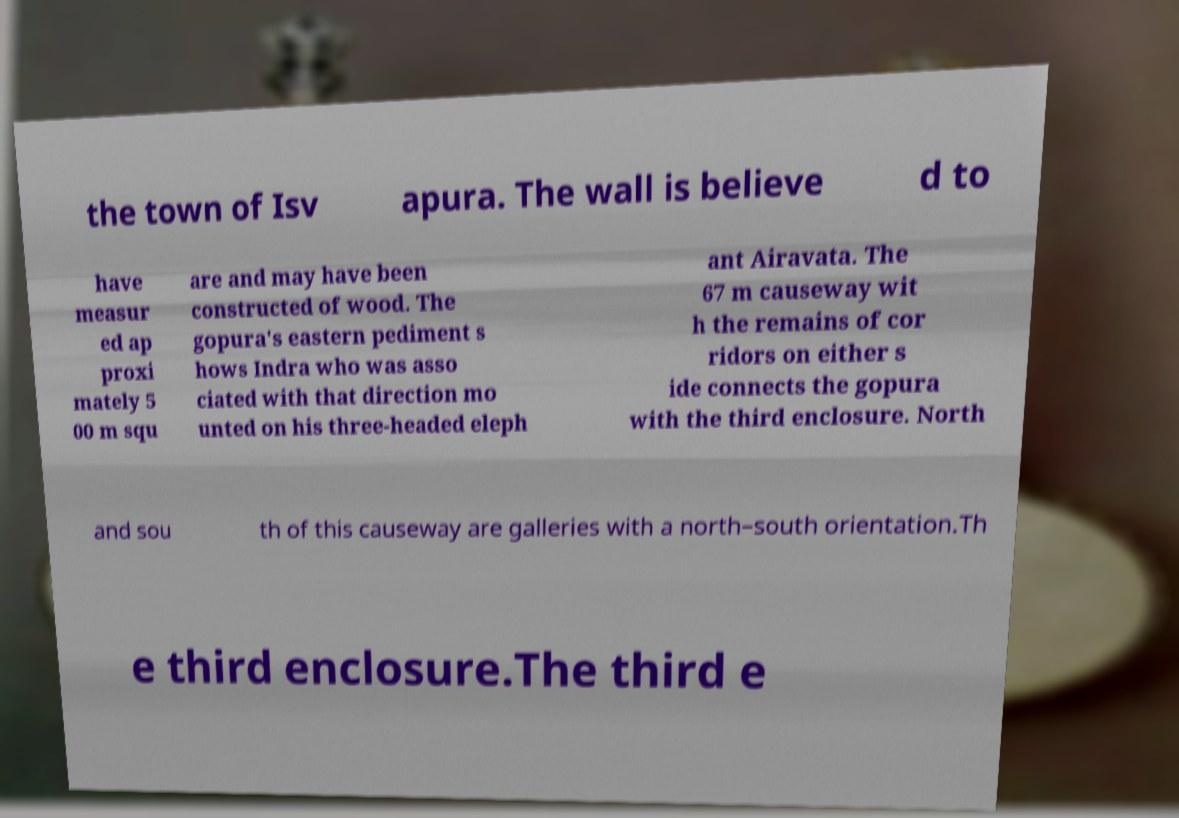I need the written content from this picture converted into text. Can you do that? the town of Isv apura. The wall is believe d to have measur ed ap proxi mately 5 00 m squ are and may have been constructed of wood. The gopura's eastern pediment s hows Indra who was asso ciated with that direction mo unted on his three-headed eleph ant Airavata. The 67 m causeway wit h the remains of cor ridors on either s ide connects the gopura with the third enclosure. North and sou th of this causeway are galleries with a north–south orientation.Th e third enclosure.The third e 